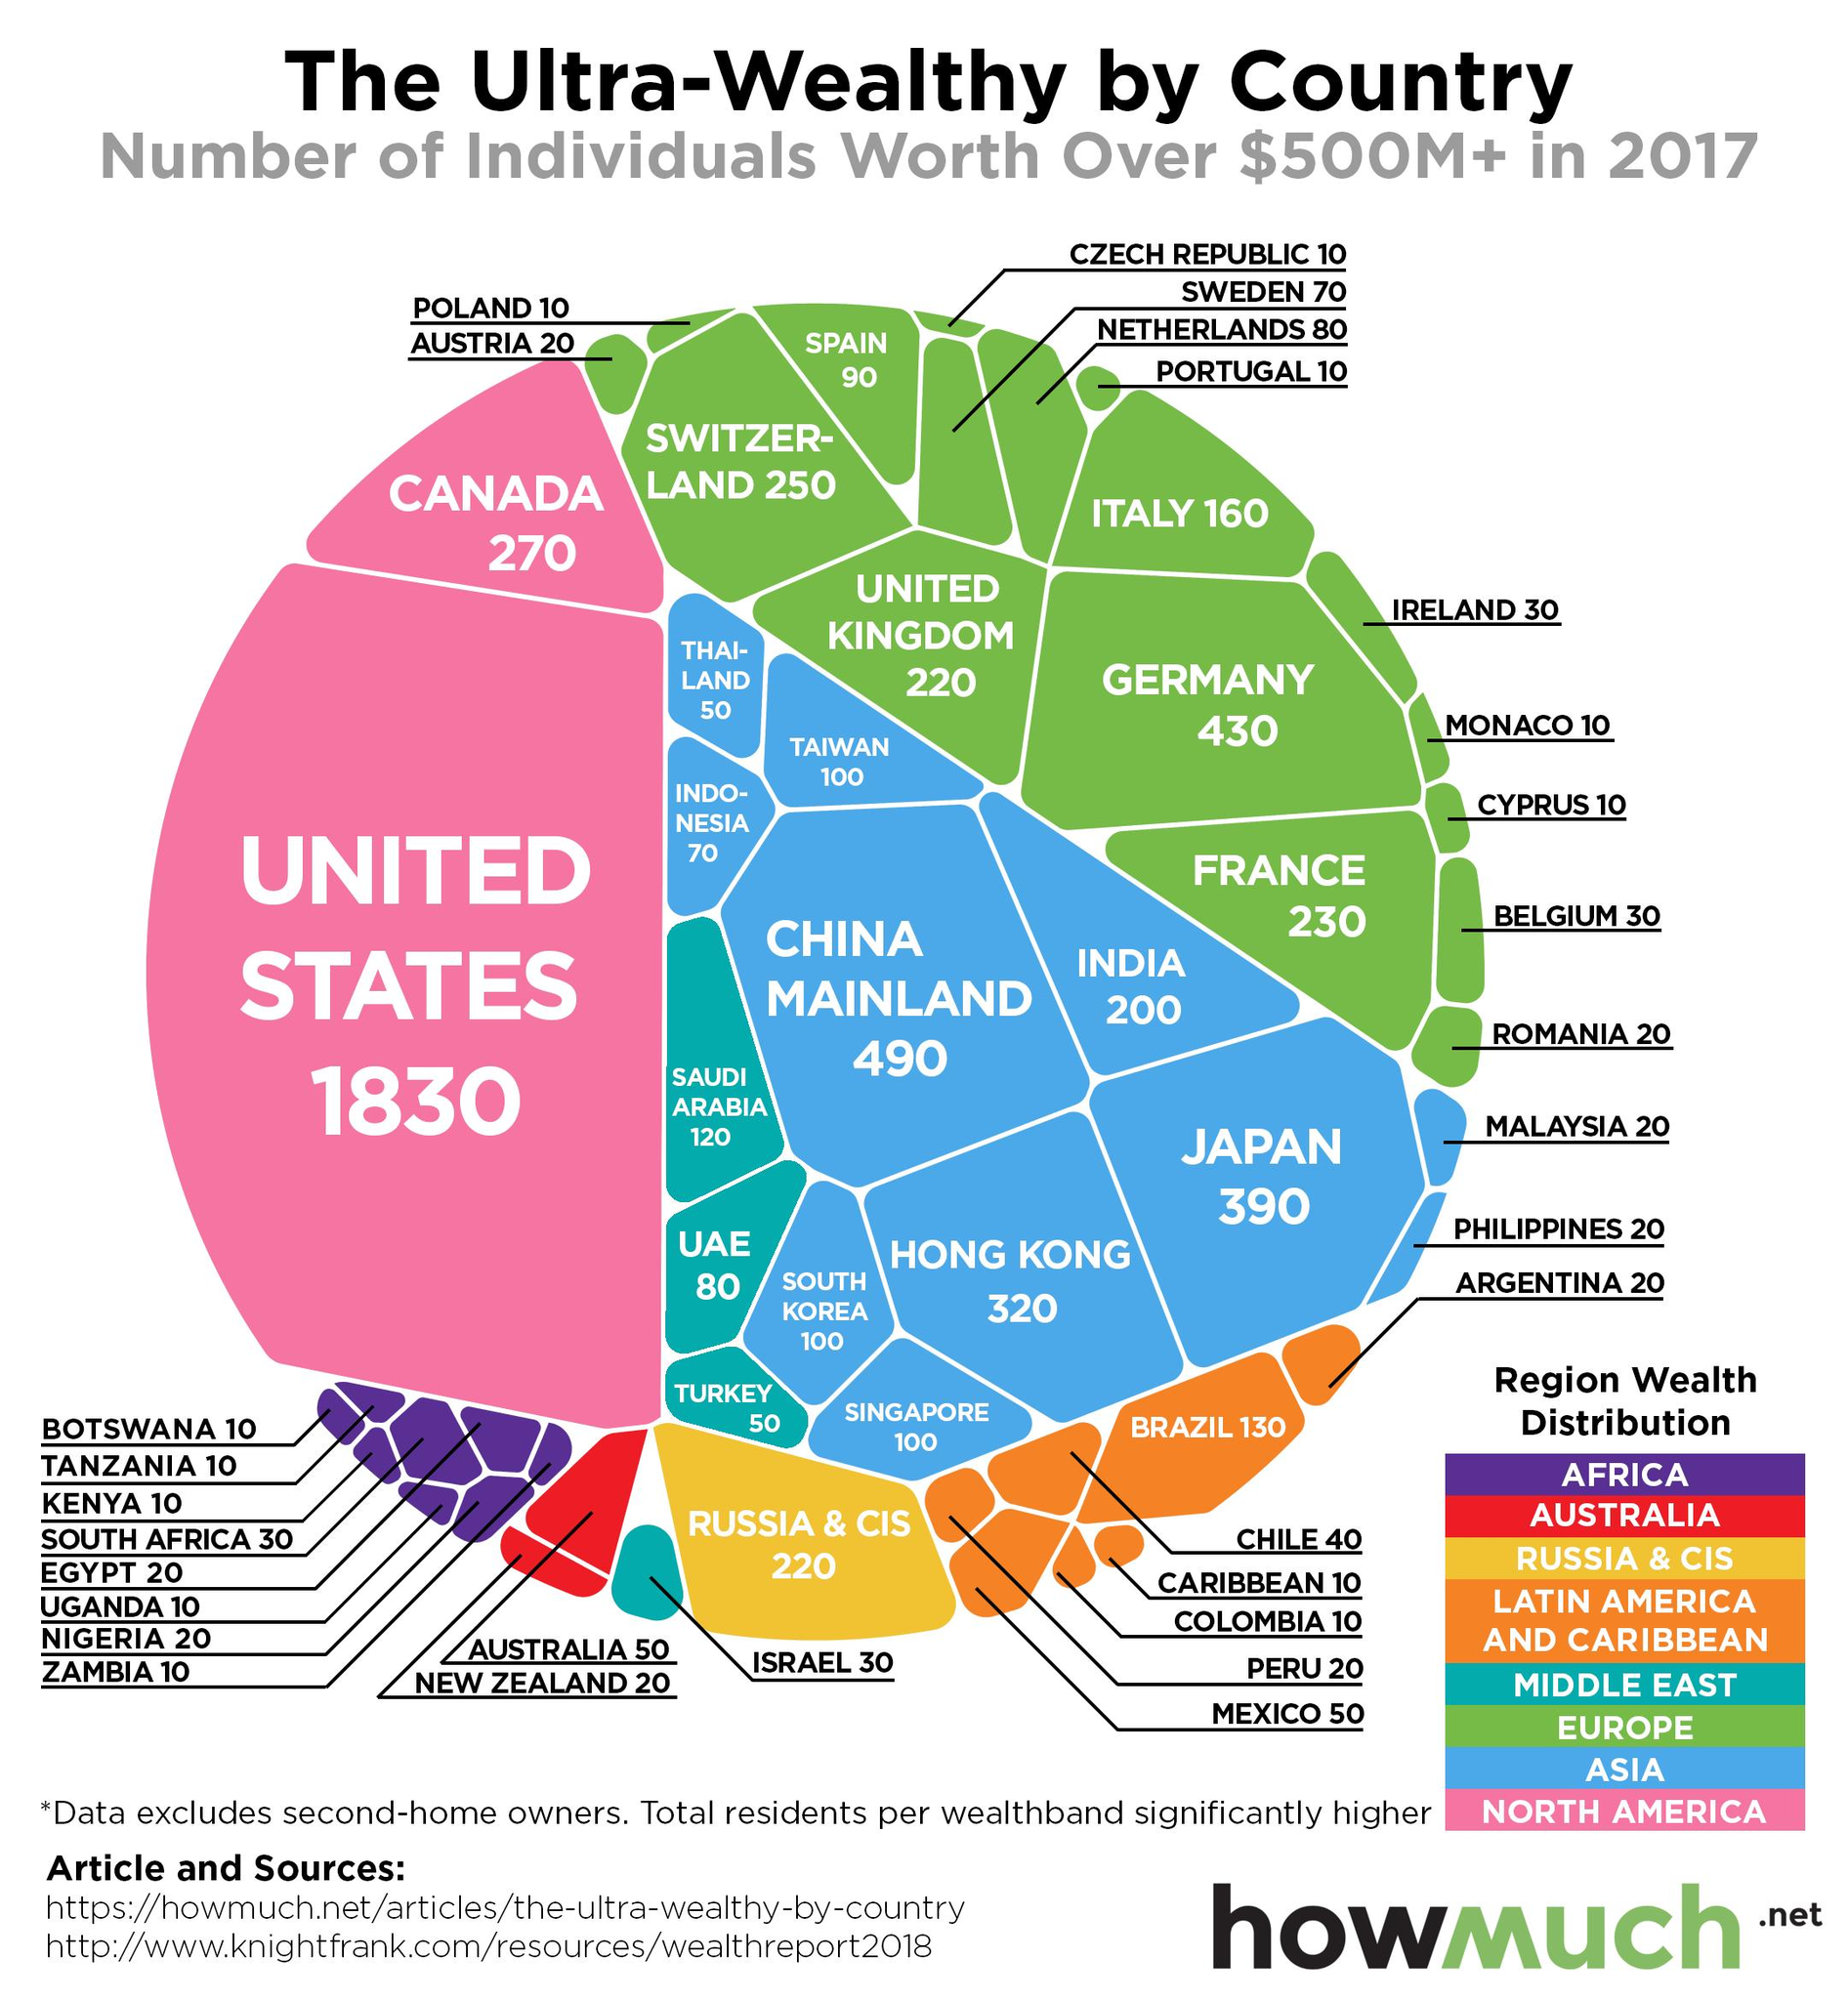Mention a couple of crucial points in this snapshot. In 2017, Thailand had the least number of ultra-wealthy individuals out of all countries in the Asian region. According to a report, in 2017, Switzerland had the second-highest number of ultra-wealthy individuals in the European region. There were approximately 80 individuals with a net worth of over $500 million in the UAE in 2017. In India in 2017, there were approximately 200 individuals with a net worth exceeding $500 million. The United States had the highest number of ultra-wealthy individuals in 2017, according to a report by the UNITED STATES. 